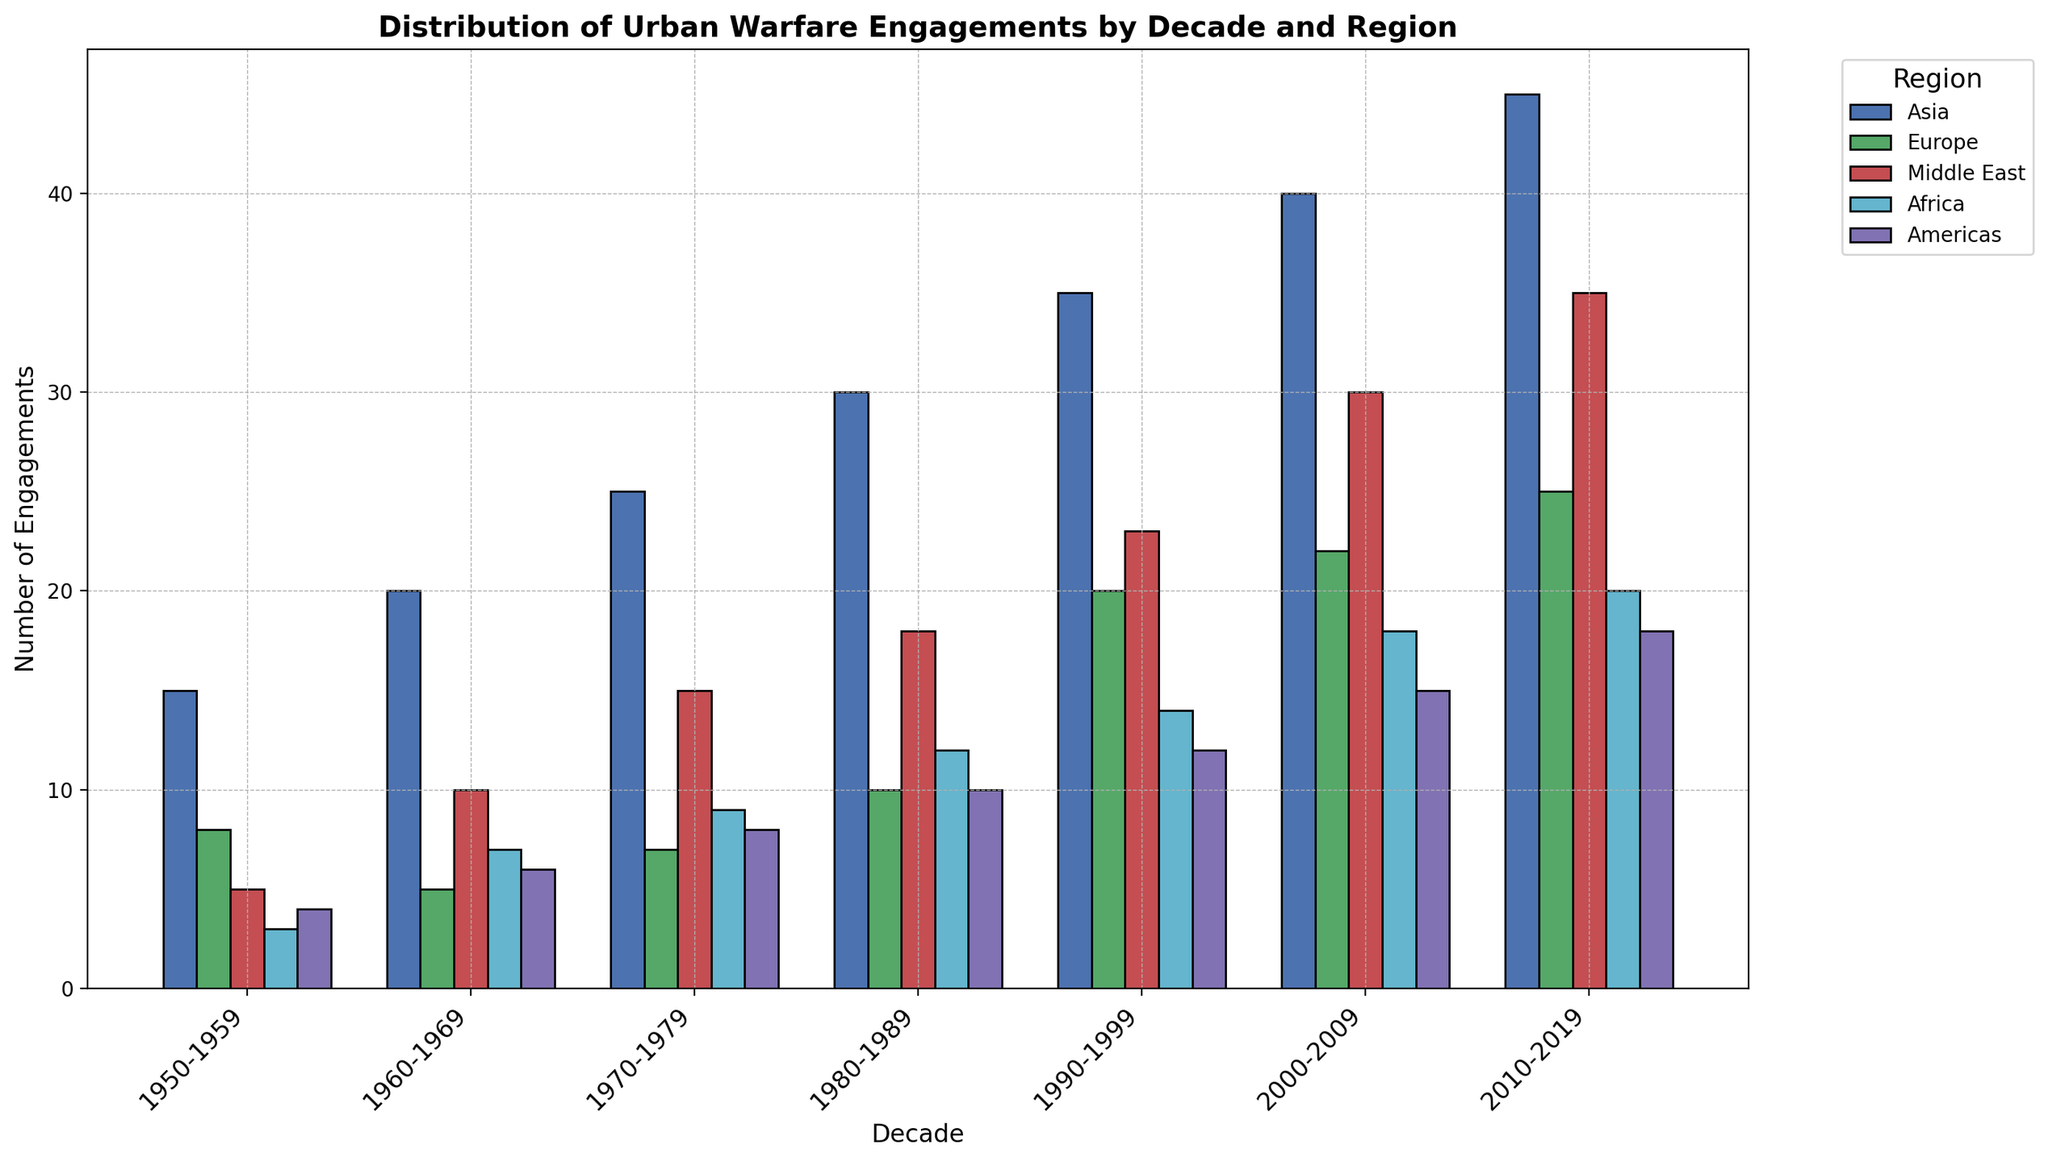What is the total number of urban warfare engagements in Asia across all decades? To find the total number of engagements in Asia, sum up the values for each decade: 15 + 20 + 25 + 30 + 35 + 40 + 45 = 210
Answer: 210 Which region had the highest number of engagements in the 2000-2009 decade? By examining the bar heights in the 2000-2009 decade, compare all the regions. Asia has the highest bar in this decade with 40 engagements.
Answer: Asia How many more engagements were there in the Middle East than in Africa in the 2010-2019 decade? Find the number of engagements for both regions in the 2010-2019 decade (Middle East: 35, Africa: 20) and subtract the two: 35 - 20 = 15
Answer: 15 In which decade did Europe see the greatest increase in engagements compared to the previous decade? Calculate the difference in engagements for each decade for Europe: (5-8=-3), (7-5=2), (10-7=3), (20-10=10), (22-20=2), (25-22=3). The largest increase is from 1980-1989 to 1990-1999, which is 10 engagements.
Answer: 1990-1999 Between the 1960-1969 and 1970-1979 decades, did the number of engagements in the Americas increase or decrease? By how much? Compare the engagements in the Americas in these two decades: 6 (1960-1969) and 8 (1970-1979). The number of engagements increased by 8 - 6 = 2.
Answer: Increased by 2 What is the average number of engagements per decade in the Middle East? Sum the number of engagements in the Middle East for each decade and divide by the number of decades: (5 + 10 + 15 + 18 + 23 + 30 + 35)/7 ≈ 135/7 ≈ 19.29
Answer: 19.29 Which decade had the lowest total number of engagements across all regions? Sum the engagements for each decade: 
1950-1959: 35, 
1960-1969: 48, 
1970-1979: 64, 
1980-1989: 80, 
1990-1999: 104, 
2000-2009: 125, 
2010-2019: 143. The 1950-1959 decade has the lowest total with 35 engagements.
Answer: 1950-1959 What color represents the Middle East in the graph? Identify the color associated with the Middle East by locating it in the legend and matching it to the bars in the graph. The Middle East is represented by the red color.
Answer: Red In the 1990-1999 decade, how does the number of engagements in Europe compare with those in the Americas? Compare the number of engagements for Europe (20) and the Americas (12) in the 1990-1999 decade. Europe has 8 more engagements than the Americas.
Answer: Europe has 8 more What is the combined number of engagements in all regions for the 1980-1989 and 1990-1999 decades? Sum the engagements in all regions for the 1980-1989 and 1990-1999 decades: 
1980-1989: 30 + 10 + 18 + 12 + 10 = 80, 
1990-1999: 35 + 20 + 23 + 14 + 12 = 104,
Total: 80 + 104 = 184.
Answer: 184 